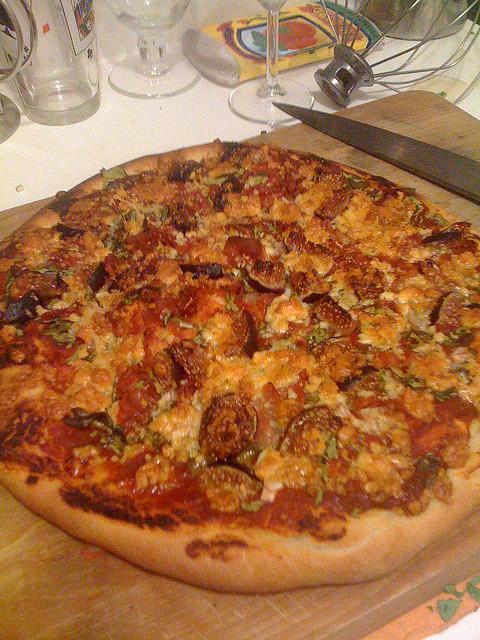How many wine glasses are in the photo?
Give a very brief answer. 2. 